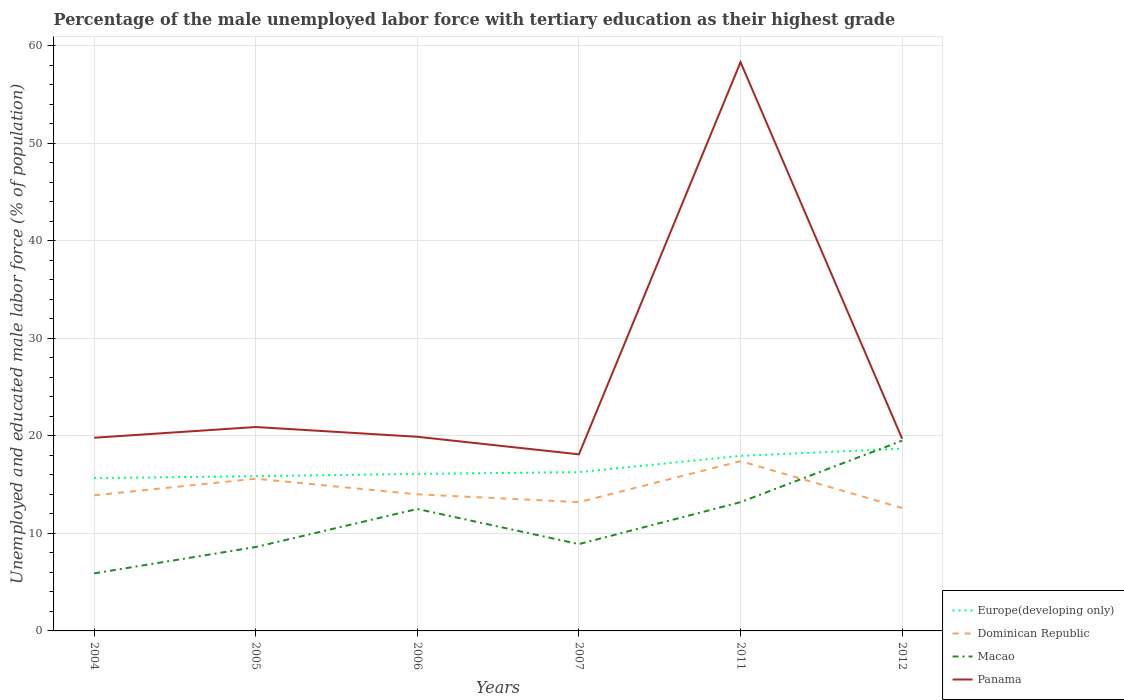Across all years, what is the maximum percentage of the unemployed male labor force with tertiary education in Panama?
Ensure brevity in your answer.  18.1. What is the total percentage of the unemployed male labor force with tertiary education in Dominican Republic in the graph?
Make the answer very short. 0.6. What is the difference between the highest and the second highest percentage of the unemployed male labor force with tertiary education in Macao?
Keep it short and to the point. 13.6. How many lines are there?
Ensure brevity in your answer.  4. Does the graph contain grids?
Provide a succinct answer. Yes. Where does the legend appear in the graph?
Offer a terse response. Bottom right. How are the legend labels stacked?
Keep it short and to the point. Vertical. What is the title of the graph?
Keep it short and to the point. Percentage of the male unemployed labor force with tertiary education as their highest grade. Does "Nepal" appear as one of the legend labels in the graph?
Give a very brief answer. No. What is the label or title of the Y-axis?
Offer a terse response. Unemployed and educated male labor force (% of population). What is the Unemployed and educated male labor force (% of population) of Europe(developing only) in 2004?
Keep it short and to the point. 15.66. What is the Unemployed and educated male labor force (% of population) of Dominican Republic in 2004?
Your answer should be very brief. 13.9. What is the Unemployed and educated male labor force (% of population) in Macao in 2004?
Provide a short and direct response. 5.9. What is the Unemployed and educated male labor force (% of population) in Panama in 2004?
Make the answer very short. 19.8. What is the Unemployed and educated male labor force (% of population) of Europe(developing only) in 2005?
Give a very brief answer. 15.86. What is the Unemployed and educated male labor force (% of population) of Dominican Republic in 2005?
Make the answer very short. 15.6. What is the Unemployed and educated male labor force (% of population) in Macao in 2005?
Your answer should be compact. 8.6. What is the Unemployed and educated male labor force (% of population) in Panama in 2005?
Keep it short and to the point. 20.9. What is the Unemployed and educated male labor force (% of population) of Europe(developing only) in 2006?
Ensure brevity in your answer.  16.1. What is the Unemployed and educated male labor force (% of population) of Dominican Republic in 2006?
Keep it short and to the point. 14. What is the Unemployed and educated male labor force (% of population) of Macao in 2006?
Offer a terse response. 12.5. What is the Unemployed and educated male labor force (% of population) in Panama in 2006?
Give a very brief answer. 19.9. What is the Unemployed and educated male labor force (% of population) of Europe(developing only) in 2007?
Give a very brief answer. 16.27. What is the Unemployed and educated male labor force (% of population) in Dominican Republic in 2007?
Give a very brief answer. 13.2. What is the Unemployed and educated male labor force (% of population) in Macao in 2007?
Your answer should be compact. 8.9. What is the Unemployed and educated male labor force (% of population) of Panama in 2007?
Ensure brevity in your answer.  18.1. What is the Unemployed and educated male labor force (% of population) of Europe(developing only) in 2011?
Keep it short and to the point. 17.94. What is the Unemployed and educated male labor force (% of population) in Dominican Republic in 2011?
Make the answer very short. 17.4. What is the Unemployed and educated male labor force (% of population) of Macao in 2011?
Provide a succinct answer. 13.2. What is the Unemployed and educated male labor force (% of population) of Panama in 2011?
Give a very brief answer. 58.3. What is the Unemployed and educated male labor force (% of population) in Europe(developing only) in 2012?
Provide a short and direct response. 18.68. What is the Unemployed and educated male labor force (% of population) in Dominican Republic in 2012?
Your answer should be compact. 12.6. What is the Unemployed and educated male labor force (% of population) of Panama in 2012?
Make the answer very short. 19.7. Across all years, what is the maximum Unemployed and educated male labor force (% of population) in Europe(developing only)?
Provide a short and direct response. 18.68. Across all years, what is the maximum Unemployed and educated male labor force (% of population) of Dominican Republic?
Keep it short and to the point. 17.4. Across all years, what is the maximum Unemployed and educated male labor force (% of population) in Macao?
Ensure brevity in your answer.  19.5. Across all years, what is the maximum Unemployed and educated male labor force (% of population) in Panama?
Make the answer very short. 58.3. Across all years, what is the minimum Unemployed and educated male labor force (% of population) of Europe(developing only)?
Your response must be concise. 15.66. Across all years, what is the minimum Unemployed and educated male labor force (% of population) of Dominican Republic?
Provide a short and direct response. 12.6. Across all years, what is the minimum Unemployed and educated male labor force (% of population) of Macao?
Ensure brevity in your answer.  5.9. Across all years, what is the minimum Unemployed and educated male labor force (% of population) of Panama?
Ensure brevity in your answer.  18.1. What is the total Unemployed and educated male labor force (% of population) in Europe(developing only) in the graph?
Provide a succinct answer. 100.52. What is the total Unemployed and educated male labor force (% of population) of Dominican Republic in the graph?
Your response must be concise. 86.7. What is the total Unemployed and educated male labor force (% of population) of Macao in the graph?
Provide a short and direct response. 68.6. What is the total Unemployed and educated male labor force (% of population) in Panama in the graph?
Your answer should be compact. 156.7. What is the difference between the Unemployed and educated male labor force (% of population) in Europe(developing only) in 2004 and that in 2005?
Offer a very short reply. -0.2. What is the difference between the Unemployed and educated male labor force (% of population) of Panama in 2004 and that in 2005?
Offer a terse response. -1.1. What is the difference between the Unemployed and educated male labor force (% of population) of Europe(developing only) in 2004 and that in 2006?
Your answer should be compact. -0.43. What is the difference between the Unemployed and educated male labor force (% of population) of Dominican Republic in 2004 and that in 2006?
Your answer should be very brief. -0.1. What is the difference between the Unemployed and educated male labor force (% of population) in Macao in 2004 and that in 2006?
Give a very brief answer. -6.6. What is the difference between the Unemployed and educated male labor force (% of population) of Panama in 2004 and that in 2006?
Provide a succinct answer. -0.1. What is the difference between the Unemployed and educated male labor force (% of population) in Europe(developing only) in 2004 and that in 2007?
Your answer should be very brief. -0.61. What is the difference between the Unemployed and educated male labor force (% of population) in Panama in 2004 and that in 2007?
Your answer should be very brief. 1.7. What is the difference between the Unemployed and educated male labor force (% of population) in Europe(developing only) in 2004 and that in 2011?
Offer a terse response. -2.28. What is the difference between the Unemployed and educated male labor force (% of population) in Panama in 2004 and that in 2011?
Your answer should be very brief. -38.5. What is the difference between the Unemployed and educated male labor force (% of population) of Europe(developing only) in 2004 and that in 2012?
Ensure brevity in your answer.  -3.02. What is the difference between the Unemployed and educated male labor force (% of population) of Panama in 2004 and that in 2012?
Offer a terse response. 0.1. What is the difference between the Unemployed and educated male labor force (% of population) in Europe(developing only) in 2005 and that in 2006?
Provide a succinct answer. -0.24. What is the difference between the Unemployed and educated male labor force (% of population) in Dominican Republic in 2005 and that in 2006?
Offer a very short reply. 1.6. What is the difference between the Unemployed and educated male labor force (% of population) in Panama in 2005 and that in 2006?
Give a very brief answer. 1. What is the difference between the Unemployed and educated male labor force (% of population) in Europe(developing only) in 2005 and that in 2007?
Give a very brief answer. -0.42. What is the difference between the Unemployed and educated male labor force (% of population) of Europe(developing only) in 2005 and that in 2011?
Give a very brief answer. -2.08. What is the difference between the Unemployed and educated male labor force (% of population) of Dominican Republic in 2005 and that in 2011?
Provide a succinct answer. -1.8. What is the difference between the Unemployed and educated male labor force (% of population) in Macao in 2005 and that in 2011?
Provide a short and direct response. -4.6. What is the difference between the Unemployed and educated male labor force (% of population) of Panama in 2005 and that in 2011?
Your response must be concise. -37.4. What is the difference between the Unemployed and educated male labor force (% of population) in Europe(developing only) in 2005 and that in 2012?
Your answer should be compact. -2.83. What is the difference between the Unemployed and educated male labor force (% of population) in Europe(developing only) in 2006 and that in 2007?
Provide a short and direct response. -0.18. What is the difference between the Unemployed and educated male labor force (% of population) of Dominican Republic in 2006 and that in 2007?
Give a very brief answer. 0.8. What is the difference between the Unemployed and educated male labor force (% of population) in Macao in 2006 and that in 2007?
Offer a very short reply. 3.6. What is the difference between the Unemployed and educated male labor force (% of population) in Panama in 2006 and that in 2007?
Keep it short and to the point. 1.8. What is the difference between the Unemployed and educated male labor force (% of population) in Europe(developing only) in 2006 and that in 2011?
Offer a terse response. -1.85. What is the difference between the Unemployed and educated male labor force (% of population) in Dominican Republic in 2006 and that in 2011?
Keep it short and to the point. -3.4. What is the difference between the Unemployed and educated male labor force (% of population) in Macao in 2006 and that in 2011?
Provide a short and direct response. -0.7. What is the difference between the Unemployed and educated male labor force (% of population) in Panama in 2006 and that in 2011?
Give a very brief answer. -38.4. What is the difference between the Unemployed and educated male labor force (% of population) of Europe(developing only) in 2006 and that in 2012?
Your answer should be compact. -2.59. What is the difference between the Unemployed and educated male labor force (% of population) in Dominican Republic in 2006 and that in 2012?
Keep it short and to the point. 1.4. What is the difference between the Unemployed and educated male labor force (% of population) in Europe(developing only) in 2007 and that in 2011?
Provide a succinct answer. -1.67. What is the difference between the Unemployed and educated male labor force (% of population) of Macao in 2007 and that in 2011?
Keep it short and to the point. -4.3. What is the difference between the Unemployed and educated male labor force (% of population) of Panama in 2007 and that in 2011?
Offer a terse response. -40.2. What is the difference between the Unemployed and educated male labor force (% of population) in Europe(developing only) in 2007 and that in 2012?
Provide a succinct answer. -2.41. What is the difference between the Unemployed and educated male labor force (% of population) of Europe(developing only) in 2011 and that in 2012?
Give a very brief answer. -0.74. What is the difference between the Unemployed and educated male labor force (% of population) in Panama in 2011 and that in 2012?
Your response must be concise. 38.6. What is the difference between the Unemployed and educated male labor force (% of population) in Europe(developing only) in 2004 and the Unemployed and educated male labor force (% of population) in Dominican Republic in 2005?
Give a very brief answer. 0.06. What is the difference between the Unemployed and educated male labor force (% of population) of Europe(developing only) in 2004 and the Unemployed and educated male labor force (% of population) of Macao in 2005?
Ensure brevity in your answer.  7.06. What is the difference between the Unemployed and educated male labor force (% of population) of Europe(developing only) in 2004 and the Unemployed and educated male labor force (% of population) of Panama in 2005?
Keep it short and to the point. -5.24. What is the difference between the Unemployed and educated male labor force (% of population) of Dominican Republic in 2004 and the Unemployed and educated male labor force (% of population) of Panama in 2005?
Your response must be concise. -7. What is the difference between the Unemployed and educated male labor force (% of population) of Macao in 2004 and the Unemployed and educated male labor force (% of population) of Panama in 2005?
Your answer should be compact. -15. What is the difference between the Unemployed and educated male labor force (% of population) in Europe(developing only) in 2004 and the Unemployed and educated male labor force (% of population) in Dominican Republic in 2006?
Offer a terse response. 1.66. What is the difference between the Unemployed and educated male labor force (% of population) in Europe(developing only) in 2004 and the Unemployed and educated male labor force (% of population) in Macao in 2006?
Your answer should be compact. 3.16. What is the difference between the Unemployed and educated male labor force (% of population) of Europe(developing only) in 2004 and the Unemployed and educated male labor force (% of population) of Panama in 2006?
Give a very brief answer. -4.24. What is the difference between the Unemployed and educated male labor force (% of population) of Macao in 2004 and the Unemployed and educated male labor force (% of population) of Panama in 2006?
Your answer should be compact. -14. What is the difference between the Unemployed and educated male labor force (% of population) of Europe(developing only) in 2004 and the Unemployed and educated male labor force (% of population) of Dominican Republic in 2007?
Ensure brevity in your answer.  2.46. What is the difference between the Unemployed and educated male labor force (% of population) of Europe(developing only) in 2004 and the Unemployed and educated male labor force (% of population) of Macao in 2007?
Make the answer very short. 6.76. What is the difference between the Unemployed and educated male labor force (% of population) in Europe(developing only) in 2004 and the Unemployed and educated male labor force (% of population) in Panama in 2007?
Your answer should be compact. -2.44. What is the difference between the Unemployed and educated male labor force (% of population) in Dominican Republic in 2004 and the Unemployed and educated male labor force (% of population) in Macao in 2007?
Provide a short and direct response. 5. What is the difference between the Unemployed and educated male labor force (% of population) of Dominican Republic in 2004 and the Unemployed and educated male labor force (% of population) of Panama in 2007?
Offer a terse response. -4.2. What is the difference between the Unemployed and educated male labor force (% of population) of Macao in 2004 and the Unemployed and educated male labor force (% of population) of Panama in 2007?
Ensure brevity in your answer.  -12.2. What is the difference between the Unemployed and educated male labor force (% of population) in Europe(developing only) in 2004 and the Unemployed and educated male labor force (% of population) in Dominican Republic in 2011?
Your answer should be compact. -1.74. What is the difference between the Unemployed and educated male labor force (% of population) in Europe(developing only) in 2004 and the Unemployed and educated male labor force (% of population) in Macao in 2011?
Offer a very short reply. 2.46. What is the difference between the Unemployed and educated male labor force (% of population) of Europe(developing only) in 2004 and the Unemployed and educated male labor force (% of population) of Panama in 2011?
Ensure brevity in your answer.  -42.64. What is the difference between the Unemployed and educated male labor force (% of population) of Dominican Republic in 2004 and the Unemployed and educated male labor force (% of population) of Macao in 2011?
Make the answer very short. 0.7. What is the difference between the Unemployed and educated male labor force (% of population) in Dominican Republic in 2004 and the Unemployed and educated male labor force (% of population) in Panama in 2011?
Provide a short and direct response. -44.4. What is the difference between the Unemployed and educated male labor force (% of population) in Macao in 2004 and the Unemployed and educated male labor force (% of population) in Panama in 2011?
Keep it short and to the point. -52.4. What is the difference between the Unemployed and educated male labor force (% of population) of Europe(developing only) in 2004 and the Unemployed and educated male labor force (% of population) of Dominican Republic in 2012?
Give a very brief answer. 3.06. What is the difference between the Unemployed and educated male labor force (% of population) of Europe(developing only) in 2004 and the Unemployed and educated male labor force (% of population) of Macao in 2012?
Make the answer very short. -3.84. What is the difference between the Unemployed and educated male labor force (% of population) in Europe(developing only) in 2004 and the Unemployed and educated male labor force (% of population) in Panama in 2012?
Ensure brevity in your answer.  -4.04. What is the difference between the Unemployed and educated male labor force (% of population) of Dominican Republic in 2004 and the Unemployed and educated male labor force (% of population) of Macao in 2012?
Your answer should be very brief. -5.6. What is the difference between the Unemployed and educated male labor force (% of population) in Europe(developing only) in 2005 and the Unemployed and educated male labor force (% of population) in Dominican Republic in 2006?
Provide a succinct answer. 1.86. What is the difference between the Unemployed and educated male labor force (% of population) in Europe(developing only) in 2005 and the Unemployed and educated male labor force (% of population) in Macao in 2006?
Provide a short and direct response. 3.36. What is the difference between the Unemployed and educated male labor force (% of population) in Europe(developing only) in 2005 and the Unemployed and educated male labor force (% of population) in Panama in 2006?
Provide a succinct answer. -4.04. What is the difference between the Unemployed and educated male labor force (% of population) in Dominican Republic in 2005 and the Unemployed and educated male labor force (% of population) in Macao in 2006?
Your answer should be compact. 3.1. What is the difference between the Unemployed and educated male labor force (% of population) in Dominican Republic in 2005 and the Unemployed and educated male labor force (% of population) in Panama in 2006?
Your response must be concise. -4.3. What is the difference between the Unemployed and educated male labor force (% of population) in Macao in 2005 and the Unemployed and educated male labor force (% of population) in Panama in 2006?
Your answer should be very brief. -11.3. What is the difference between the Unemployed and educated male labor force (% of population) in Europe(developing only) in 2005 and the Unemployed and educated male labor force (% of population) in Dominican Republic in 2007?
Your answer should be compact. 2.66. What is the difference between the Unemployed and educated male labor force (% of population) in Europe(developing only) in 2005 and the Unemployed and educated male labor force (% of population) in Macao in 2007?
Give a very brief answer. 6.96. What is the difference between the Unemployed and educated male labor force (% of population) of Europe(developing only) in 2005 and the Unemployed and educated male labor force (% of population) of Panama in 2007?
Provide a succinct answer. -2.24. What is the difference between the Unemployed and educated male labor force (% of population) in Dominican Republic in 2005 and the Unemployed and educated male labor force (% of population) in Panama in 2007?
Your answer should be very brief. -2.5. What is the difference between the Unemployed and educated male labor force (% of population) in Europe(developing only) in 2005 and the Unemployed and educated male labor force (% of population) in Dominican Republic in 2011?
Keep it short and to the point. -1.54. What is the difference between the Unemployed and educated male labor force (% of population) in Europe(developing only) in 2005 and the Unemployed and educated male labor force (% of population) in Macao in 2011?
Ensure brevity in your answer.  2.66. What is the difference between the Unemployed and educated male labor force (% of population) in Europe(developing only) in 2005 and the Unemployed and educated male labor force (% of population) in Panama in 2011?
Ensure brevity in your answer.  -42.44. What is the difference between the Unemployed and educated male labor force (% of population) in Dominican Republic in 2005 and the Unemployed and educated male labor force (% of population) in Macao in 2011?
Make the answer very short. 2.4. What is the difference between the Unemployed and educated male labor force (% of population) in Dominican Republic in 2005 and the Unemployed and educated male labor force (% of population) in Panama in 2011?
Make the answer very short. -42.7. What is the difference between the Unemployed and educated male labor force (% of population) of Macao in 2005 and the Unemployed and educated male labor force (% of population) of Panama in 2011?
Provide a succinct answer. -49.7. What is the difference between the Unemployed and educated male labor force (% of population) of Europe(developing only) in 2005 and the Unemployed and educated male labor force (% of population) of Dominican Republic in 2012?
Your answer should be compact. 3.26. What is the difference between the Unemployed and educated male labor force (% of population) of Europe(developing only) in 2005 and the Unemployed and educated male labor force (% of population) of Macao in 2012?
Offer a terse response. -3.64. What is the difference between the Unemployed and educated male labor force (% of population) in Europe(developing only) in 2005 and the Unemployed and educated male labor force (% of population) in Panama in 2012?
Offer a terse response. -3.84. What is the difference between the Unemployed and educated male labor force (% of population) of Macao in 2005 and the Unemployed and educated male labor force (% of population) of Panama in 2012?
Give a very brief answer. -11.1. What is the difference between the Unemployed and educated male labor force (% of population) in Europe(developing only) in 2006 and the Unemployed and educated male labor force (% of population) in Dominican Republic in 2007?
Offer a very short reply. 2.9. What is the difference between the Unemployed and educated male labor force (% of population) in Europe(developing only) in 2006 and the Unemployed and educated male labor force (% of population) in Macao in 2007?
Provide a succinct answer. 7.2. What is the difference between the Unemployed and educated male labor force (% of population) in Europe(developing only) in 2006 and the Unemployed and educated male labor force (% of population) in Panama in 2007?
Make the answer very short. -2. What is the difference between the Unemployed and educated male labor force (% of population) in Dominican Republic in 2006 and the Unemployed and educated male labor force (% of population) in Panama in 2007?
Your answer should be compact. -4.1. What is the difference between the Unemployed and educated male labor force (% of population) in Europe(developing only) in 2006 and the Unemployed and educated male labor force (% of population) in Dominican Republic in 2011?
Provide a succinct answer. -1.3. What is the difference between the Unemployed and educated male labor force (% of population) in Europe(developing only) in 2006 and the Unemployed and educated male labor force (% of population) in Macao in 2011?
Offer a terse response. 2.9. What is the difference between the Unemployed and educated male labor force (% of population) in Europe(developing only) in 2006 and the Unemployed and educated male labor force (% of population) in Panama in 2011?
Provide a succinct answer. -42.2. What is the difference between the Unemployed and educated male labor force (% of population) in Dominican Republic in 2006 and the Unemployed and educated male labor force (% of population) in Panama in 2011?
Give a very brief answer. -44.3. What is the difference between the Unemployed and educated male labor force (% of population) in Macao in 2006 and the Unemployed and educated male labor force (% of population) in Panama in 2011?
Make the answer very short. -45.8. What is the difference between the Unemployed and educated male labor force (% of population) of Europe(developing only) in 2006 and the Unemployed and educated male labor force (% of population) of Dominican Republic in 2012?
Offer a very short reply. 3.5. What is the difference between the Unemployed and educated male labor force (% of population) in Europe(developing only) in 2006 and the Unemployed and educated male labor force (% of population) in Macao in 2012?
Your answer should be compact. -3.4. What is the difference between the Unemployed and educated male labor force (% of population) of Europe(developing only) in 2006 and the Unemployed and educated male labor force (% of population) of Panama in 2012?
Provide a succinct answer. -3.6. What is the difference between the Unemployed and educated male labor force (% of population) in Dominican Republic in 2006 and the Unemployed and educated male labor force (% of population) in Macao in 2012?
Provide a short and direct response. -5.5. What is the difference between the Unemployed and educated male labor force (% of population) of Dominican Republic in 2006 and the Unemployed and educated male labor force (% of population) of Panama in 2012?
Make the answer very short. -5.7. What is the difference between the Unemployed and educated male labor force (% of population) in Europe(developing only) in 2007 and the Unemployed and educated male labor force (% of population) in Dominican Republic in 2011?
Offer a very short reply. -1.13. What is the difference between the Unemployed and educated male labor force (% of population) of Europe(developing only) in 2007 and the Unemployed and educated male labor force (% of population) of Macao in 2011?
Offer a terse response. 3.07. What is the difference between the Unemployed and educated male labor force (% of population) in Europe(developing only) in 2007 and the Unemployed and educated male labor force (% of population) in Panama in 2011?
Your response must be concise. -42.03. What is the difference between the Unemployed and educated male labor force (% of population) in Dominican Republic in 2007 and the Unemployed and educated male labor force (% of population) in Macao in 2011?
Provide a succinct answer. 0. What is the difference between the Unemployed and educated male labor force (% of population) of Dominican Republic in 2007 and the Unemployed and educated male labor force (% of population) of Panama in 2011?
Provide a succinct answer. -45.1. What is the difference between the Unemployed and educated male labor force (% of population) of Macao in 2007 and the Unemployed and educated male labor force (% of population) of Panama in 2011?
Ensure brevity in your answer.  -49.4. What is the difference between the Unemployed and educated male labor force (% of population) of Europe(developing only) in 2007 and the Unemployed and educated male labor force (% of population) of Dominican Republic in 2012?
Make the answer very short. 3.67. What is the difference between the Unemployed and educated male labor force (% of population) in Europe(developing only) in 2007 and the Unemployed and educated male labor force (% of population) in Macao in 2012?
Keep it short and to the point. -3.23. What is the difference between the Unemployed and educated male labor force (% of population) in Europe(developing only) in 2007 and the Unemployed and educated male labor force (% of population) in Panama in 2012?
Make the answer very short. -3.43. What is the difference between the Unemployed and educated male labor force (% of population) of Macao in 2007 and the Unemployed and educated male labor force (% of population) of Panama in 2012?
Provide a succinct answer. -10.8. What is the difference between the Unemployed and educated male labor force (% of population) in Europe(developing only) in 2011 and the Unemployed and educated male labor force (% of population) in Dominican Republic in 2012?
Offer a very short reply. 5.34. What is the difference between the Unemployed and educated male labor force (% of population) in Europe(developing only) in 2011 and the Unemployed and educated male labor force (% of population) in Macao in 2012?
Give a very brief answer. -1.56. What is the difference between the Unemployed and educated male labor force (% of population) of Europe(developing only) in 2011 and the Unemployed and educated male labor force (% of population) of Panama in 2012?
Offer a terse response. -1.76. What is the difference between the Unemployed and educated male labor force (% of population) in Dominican Republic in 2011 and the Unemployed and educated male labor force (% of population) in Macao in 2012?
Your response must be concise. -2.1. What is the difference between the Unemployed and educated male labor force (% of population) in Macao in 2011 and the Unemployed and educated male labor force (% of population) in Panama in 2012?
Offer a terse response. -6.5. What is the average Unemployed and educated male labor force (% of population) of Europe(developing only) per year?
Ensure brevity in your answer.  16.75. What is the average Unemployed and educated male labor force (% of population) of Dominican Republic per year?
Offer a very short reply. 14.45. What is the average Unemployed and educated male labor force (% of population) of Macao per year?
Your answer should be compact. 11.43. What is the average Unemployed and educated male labor force (% of population) of Panama per year?
Provide a succinct answer. 26.12. In the year 2004, what is the difference between the Unemployed and educated male labor force (% of population) of Europe(developing only) and Unemployed and educated male labor force (% of population) of Dominican Republic?
Your response must be concise. 1.76. In the year 2004, what is the difference between the Unemployed and educated male labor force (% of population) of Europe(developing only) and Unemployed and educated male labor force (% of population) of Macao?
Your response must be concise. 9.76. In the year 2004, what is the difference between the Unemployed and educated male labor force (% of population) in Europe(developing only) and Unemployed and educated male labor force (% of population) in Panama?
Your answer should be compact. -4.14. In the year 2004, what is the difference between the Unemployed and educated male labor force (% of population) in Dominican Republic and Unemployed and educated male labor force (% of population) in Macao?
Provide a short and direct response. 8. In the year 2004, what is the difference between the Unemployed and educated male labor force (% of population) in Dominican Republic and Unemployed and educated male labor force (% of population) in Panama?
Offer a terse response. -5.9. In the year 2005, what is the difference between the Unemployed and educated male labor force (% of population) in Europe(developing only) and Unemployed and educated male labor force (% of population) in Dominican Republic?
Your answer should be compact. 0.26. In the year 2005, what is the difference between the Unemployed and educated male labor force (% of population) in Europe(developing only) and Unemployed and educated male labor force (% of population) in Macao?
Your answer should be very brief. 7.26. In the year 2005, what is the difference between the Unemployed and educated male labor force (% of population) of Europe(developing only) and Unemployed and educated male labor force (% of population) of Panama?
Keep it short and to the point. -5.04. In the year 2005, what is the difference between the Unemployed and educated male labor force (% of population) in Dominican Republic and Unemployed and educated male labor force (% of population) in Panama?
Ensure brevity in your answer.  -5.3. In the year 2005, what is the difference between the Unemployed and educated male labor force (% of population) in Macao and Unemployed and educated male labor force (% of population) in Panama?
Provide a succinct answer. -12.3. In the year 2006, what is the difference between the Unemployed and educated male labor force (% of population) in Europe(developing only) and Unemployed and educated male labor force (% of population) in Dominican Republic?
Offer a terse response. 2.1. In the year 2006, what is the difference between the Unemployed and educated male labor force (% of population) of Europe(developing only) and Unemployed and educated male labor force (% of population) of Macao?
Ensure brevity in your answer.  3.6. In the year 2006, what is the difference between the Unemployed and educated male labor force (% of population) in Europe(developing only) and Unemployed and educated male labor force (% of population) in Panama?
Provide a short and direct response. -3.8. In the year 2006, what is the difference between the Unemployed and educated male labor force (% of population) of Dominican Republic and Unemployed and educated male labor force (% of population) of Macao?
Provide a short and direct response. 1.5. In the year 2006, what is the difference between the Unemployed and educated male labor force (% of population) of Dominican Republic and Unemployed and educated male labor force (% of population) of Panama?
Ensure brevity in your answer.  -5.9. In the year 2006, what is the difference between the Unemployed and educated male labor force (% of population) in Macao and Unemployed and educated male labor force (% of population) in Panama?
Your answer should be very brief. -7.4. In the year 2007, what is the difference between the Unemployed and educated male labor force (% of population) of Europe(developing only) and Unemployed and educated male labor force (% of population) of Dominican Republic?
Offer a very short reply. 3.07. In the year 2007, what is the difference between the Unemployed and educated male labor force (% of population) in Europe(developing only) and Unemployed and educated male labor force (% of population) in Macao?
Your answer should be compact. 7.37. In the year 2007, what is the difference between the Unemployed and educated male labor force (% of population) in Europe(developing only) and Unemployed and educated male labor force (% of population) in Panama?
Offer a very short reply. -1.83. In the year 2007, what is the difference between the Unemployed and educated male labor force (% of population) of Dominican Republic and Unemployed and educated male labor force (% of population) of Panama?
Your response must be concise. -4.9. In the year 2007, what is the difference between the Unemployed and educated male labor force (% of population) in Macao and Unemployed and educated male labor force (% of population) in Panama?
Keep it short and to the point. -9.2. In the year 2011, what is the difference between the Unemployed and educated male labor force (% of population) in Europe(developing only) and Unemployed and educated male labor force (% of population) in Dominican Republic?
Offer a very short reply. 0.54. In the year 2011, what is the difference between the Unemployed and educated male labor force (% of population) of Europe(developing only) and Unemployed and educated male labor force (% of population) of Macao?
Keep it short and to the point. 4.74. In the year 2011, what is the difference between the Unemployed and educated male labor force (% of population) in Europe(developing only) and Unemployed and educated male labor force (% of population) in Panama?
Offer a terse response. -40.36. In the year 2011, what is the difference between the Unemployed and educated male labor force (% of population) in Dominican Republic and Unemployed and educated male labor force (% of population) in Panama?
Keep it short and to the point. -40.9. In the year 2011, what is the difference between the Unemployed and educated male labor force (% of population) in Macao and Unemployed and educated male labor force (% of population) in Panama?
Give a very brief answer. -45.1. In the year 2012, what is the difference between the Unemployed and educated male labor force (% of population) in Europe(developing only) and Unemployed and educated male labor force (% of population) in Dominican Republic?
Offer a very short reply. 6.08. In the year 2012, what is the difference between the Unemployed and educated male labor force (% of population) of Europe(developing only) and Unemployed and educated male labor force (% of population) of Macao?
Your answer should be compact. -0.82. In the year 2012, what is the difference between the Unemployed and educated male labor force (% of population) of Europe(developing only) and Unemployed and educated male labor force (% of population) of Panama?
Ensure brevity in your answer.  -1.02. In the year 2012, what is the difference between the Unemployed and educated male labor force (% of population) in Dominican Republic and Unemployed and educated male labor force (% of population) in Macao?
Provide a succinct answer. -6.9. In the year 2012, what is the difference between the Unemployed and educated male labor force (% of population) in Macao and Unemployed and educated male labor force (% of population) in Panama?
Your answer should be very brief. -0.2. What is the ratio of the Unemployed and educated male labor force (% of population) in Europe(developing only) in 2004 to that in 2005?
Your answer should be compact. 0.99. What is the ratio of the Unemployed and educated male labor force (% of population) in Dominican Republic in 2004 to that in 2005?
Your response must be concise. 0.89. What is the ratio of the Unemployed and educated male labor force (% of population) in Macao in 2004 to that in 2005?
Offer a very short reply. 0.69. What is the ratio of the Unemployed and educated male labor force (% of population) of Europe(developing only) in 2004 to that in 2006?
Keep it short and to the point. 0.97. What is the ratio of the Unemployed and educated male labor force (% of population) in Macao in 2004 to that in 2006?
Ensure brevity in your answer.  0.47. What is the ratio of the Unemployed and educated male labor force (% of population) of Panama in 2004 to that in 2006?
Your answer should be very brief. 0.99. What is the ratio of the Unemployed and educated male labor force (% of population) of Europe(developing only) in 2004 to that in 2007?
Give a very brief answer. 0.96. What is the ratio of the Unemployed and educated male labor force (% of population) of Dominican Republic in 2004 to that in 2007?
Provide a succinct answer. 1.05. What is the ratio of the Unemployed and educated male labor force (% of population) of Macao in 2004 to that in 2007?
Ensure brevity in your answer.  0.66. What is the ratio of the Unemployed and educated male labor force (% of population) of Panama in 2004 to that in 2007?
Keep it short and to the point. 1.09. What is the ratio of the Unemployed and educated male labor force (% of population) in Europe(developing only) in 2004 to that in 2011?
Provide a succinct answer. 0.87. What is the ratio of the Unemployed and educated male labor force (% of population) of Dominican Republic in 2004 to that in 2011?
Give a very brief answer. 0.8. What is the ratio of the Unemployed and educated male labor force (% of population) of Macao in 2004 to that in 2011?
Provide a succinct answer. 0.45. What is the ratio of the Unemployed and educated male labor force (% of population) of Panama in 2004 to that in 2011?
Keep it short and to the point. 0.34. What is the ratio of the Unemployed and educated male labor force (% of population) in Europe(developing only) in 2004 to that in 2012?
Your answer should be compact. 0.84. What is the ratio of the Unemployed and educated male labor force (% of population) of Dominican Republic in 2004 to that in 2012?
Offer a terse response. 1.1. What is the ratio of the Unemployed and educated male labor force (% of population) in Macao in 2004 to that in 2012?
Ensure brevity in your answer.  0.3. What is the ratio of the Unemployed and educated male labor force (% of population) of Panama in 2004 to that in 2012?
Ensure brevity in your answer.  1.01. What is the ratio of the Unemployed and educated male labor force (% of population) of Dominican Republic in 2005 to that in 2006?
Provide a short and direct response. 1.11. What is the ratio of the Unemployed and educated male labor force (% of population) in Macao in 2005 to that in 2006?
Your answer should be compact. 0.69. What is the ratio of the Unemployed and educated male labor force (% of population) of Panama in 2005 to that in 2006?
Offer a very short reply. 1.05. What is the ratio of the Unemployed and educated male labor force (% of population) of Europe(developing only) in 2005 to that in 2007?
Ensure brevity in your answer.  0.97. What is the ratio of the Unemployed and educated male labor force (% of population) in Dominican Republic in 2005 to that in 2007?
Keep it short and to the point. 1.18. What is the ratio of the Unemployed and educated male labor force (% of population) in Macao in 2005 to that in 2007?
Provide a succinct answer. 0.97. What is the ratio of the Unemployed and educated male labor force (% of population) of Panama in 2005 to that in 2007?
Offer a terse response. 1.15. What is the ratio of the Unemployed and educated male labor force (% of population) in Europe(developing only) in 2005 to that in 2011?
Your answer should be compact. 0.88. What is the ratio of the Unemployed and educated male labor force (% of population) in Dominican Republic in 2005 to that in 2011?
Give a very brief answer. 0.9. What is the ratio of the Unemployed and educated male labor force (% of population) in Macao in 2005 to that in 2011?
Your response must be concise. 0.65. What is the ratio of the Unemployed and educated male labor force (% of population) in Panama in 2005 to that in 2011?
Keep it short and to the point. 0.36. What is the ratio of the Unemployed and educated male labor force (% of population) in Europe(developing only) in 2005 to that in 2012?
Provide a short and direct response. 0.85. What is the ratio of the Unemployed and educated male labor force (% of population) of Dominican Republic in 2005 to that in 2012?
Provide a short and direct response. 1.24. What is the ratio of the Unemployed and educated male labor force (% of population) of Macao in 2005 to that in 2012?
Offer a terse response. 0.44. What is the ratio of the Unemployed and educated male labor force (% of population) in Panama in 2005 to that in 2012?
Make the answer very short. 1.06. What is the ratio of the Unemployed and educated male labor force (% of population) of Dominican Republic in 2006 to that in 2007?
Make the answer very short. 1.06. What is the ratio of the Unemployed and educated male labor force (% of population) in Macao in 2006 to that in 2007?
Make the answer very short. 1.4. What is the ratio of the Unemployed and educated male labor force (% of population) in Panama in 2006 to that in 2007?
Your response must be concise. 1.1. What is the ratio of the Unemployed and educated male labor force (% of population) of Europe(developing only) in 2006 to that in 2011?
Ensure brevity in your answer.  0.9. What is the ratio of the Unemployed and educated male labor force (% of population) in Dominican Republic in 2006 to that in 2011?
Offer a terse response. 0.8. What is the ratio of the Unemployed and educated male labor force (% of population) in Macao in 2006 to that in 2011?
Your response must be concise. 0.95. What is the ratio of the Unemployed and educated male labor force (% of population) of Panama in 2006 to that in 2011?
Offer a very short reply. 0.34. What is the ratio of the Unemployed and educated male labor force (% of population) in Europe(developing only) in 2006 to that in 2012?
Offer a terse response. 0.86. What is the ratio of the Unemployed and educated male labor force (% of population) in Dominican Republic in 2006 to that in 2012?
Your response must be concise. 1.11. What is the ratio of the Unemployed and educated male labor force (% of population) of Macao in 2006 to that in 2012?
Your response must be concise. 0.64. What is the ratio of the Unemployed and educated male labor force (% of population) of Panama in 2006 to that in 2012?
Provide a succinct answer. 1.01. What is the ratio of the Unemployed and educated male labor force (% of population) in Europe(developing only) in 2007 to that in 2011?
Offer a terse response. 0.91. What is the ratio of the Unemployed and educated male labor force (% of population) in Dominican Republic in 2007 to that in 2011?
Provide a succinct answer. 0.76. What is the ratio of the Unemployed and educated male labor force (% of population) of Macao in 2007 to that in 2011?
Provide a succinct answer. 0.67. What is the ratio of the Unemployed and educated male labor force (% of population) in Panama in 2007 to that in 2011?
Offer a very short reply. 0.31. What is the ratio of the Unemployed and educated male labor force (% of population) in Europe(developing only) in 2007 to that in 2012?
Provide a short and direct response. 0.87. What is the ratio of the Unemployed and educated male labor force (% of population) of Dominican Republic in 2007 to that in 2012?
Keep it short and to the point. 1.05. What is the ratio of the Unemployed and educated male labor force (% of population) in Macao in 2007 to that in 2012?
Your response must be concise. 0.46. What is the ratio of the Unemployed and educated male labor force (% of population) of Panama in 2007 to that in 2012?
Offer a terse response. 0.92. What is the ratio of the Unemployed and educated male labor force (% of population) in Europe(developing only) in 2011 to that in 2012?
Give a very brief answer. 0.96. What is the ratio of the Unemployed and educated male labor force (% of population) of Dominican Republic in 2011 to that in 2012?
Ensure brevity in your answer.  1.38. What is the ratio of the Unemployed and educated male labor force (% of population) of Macao in 2011 to that in 2012?
Your answer should be compact. 0.68. What is the ratio of the Unemployed and educated male labor force (% of population) in Panama in 2011 to that in 2012?
Your response must be concise. 2.96. What is the difference between the highest and the second highest Unemployed and educated male labor force (% of population) in Europe(developing only)?
Keep it short and to the point. 0.74. What is the difference between the highest and the second highest Unemployed and educated male labor force (% of population) in Dominican Republic?
Your response must be concise. 1.8. What is the difference between the highest and the second highest Unemployed and educated male labor force (% of population) of Panama?
Your answer should be compact. 37.4. What is the difference between the highest and the lowest Unemployed and educated male labor force (% of population) in Europe(developing only)?
Provide a short and direct response. 3.02. What is the difference between the highest and the lowest Unemployed and educated male labor force (% of population) in Macao?
Give a very brief answer. 13.6. What is the difference between the highest and the lowest Unemployed and educated male labor force (% of population) of Panama?
Provide a succinct answer. 40.2. 